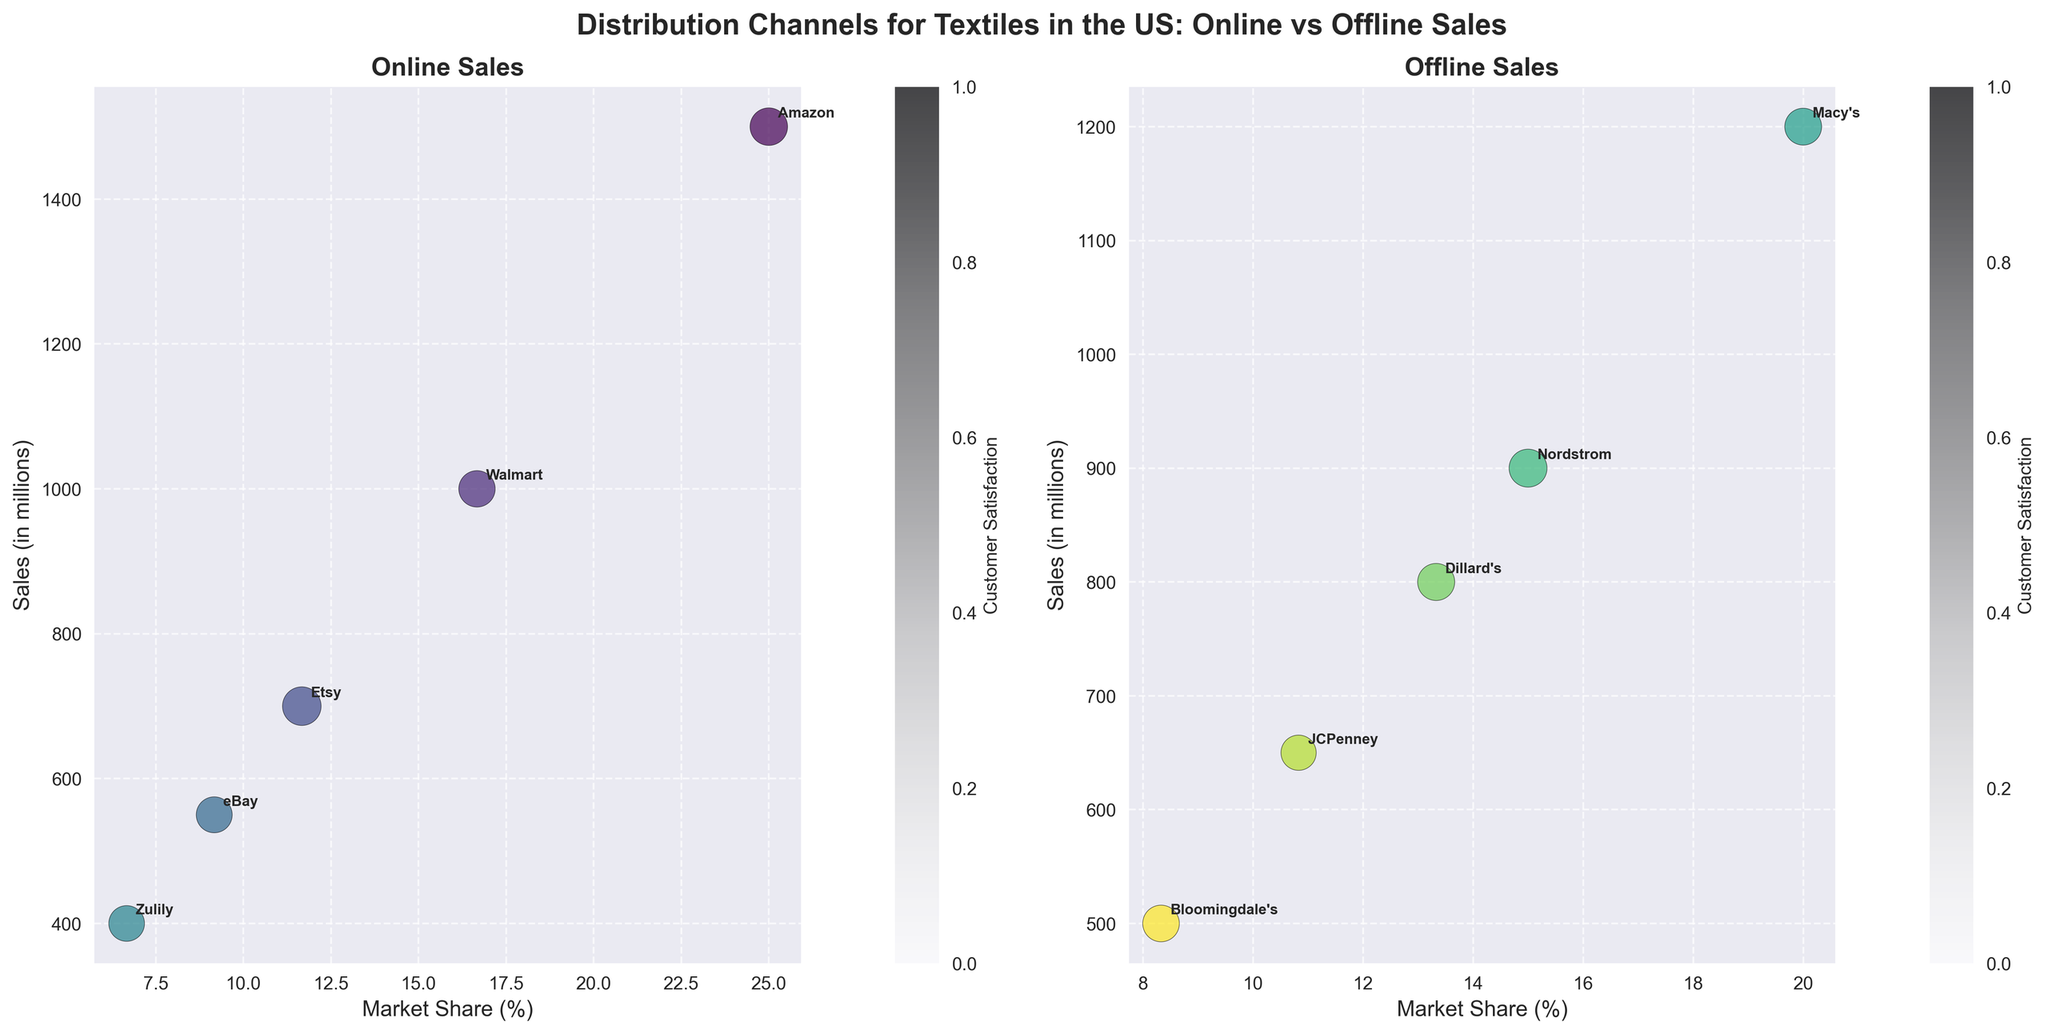What's the title of the subplot? The title is located at the top center of the subplot and summarizes the main idea, which is "Distribution Channels for Textiles in the US: Online vs Offline Sales".
Answer: Distribution Channels for Textiles in the US: Online vs Offline Sales Which company has the highest customer satisfaction in the Online Sales subplot? By examining the bubbles in the Online Sales subplot and checking the customer satisfaction color legend, we can identify that Etsy has the highest customer satisfaction with a value of 90.
Answer: Etsy Which company has the largest market share in the Offline Sales subplot? In the Offline Sales subplot, the company with the largest market share has the furthest right bubble on the x-axis. Macy's bubble is positioned at the highest market share percentage of 20%.
Answer: Macy's What's the approximate size of the bubble for Amazon in the Online Sales subplot? The size of the bubble corresponds to customer satisfaction. The bubble size is proportional, and since Amazon has a customer satisfaction of 85, its bubble size is around 425 (85 * 5).
Answer: 425 Which Online Sales company has lower sales than Dillard's in Offline Sales, but higher customer satisfaction? To find this, we locate Dillard's sales in Offline Sales (800 million) and compare them with Online Sales. Etsy has lower sales (700 million) but a higher customer satisfaction (90).
Answer: Etsy How does the market share of Nordstrom compare to that of Walmart? By comparing the x-axis positions of Nordstrom in the Offline Sales subplot and Walmart in the Online Sales subplot, we see that Nordstrom's market share (15%) is less than Walmart's market share (16.67%).
Answer: Nordstrom has a smaller market share than Walmart What's the average market share of the top three online retailers in terms of sales? The top three online retailers in terms of sales are Amazon (25%), Walmart (16.67%), and Etsy (11.67%). The average is calculated as (25 + 16.67 + 11.67) / 3.
Answer: 17.78% Which subplot has more companies represented, Online or Offline Sales? By counting the number of bubbles in each subplot, we see that the Offline Sales subplot has more companies (5) compared to the Online Sales subplot (5). Both subplots have equal representation.
Answer: Both have equal representation Is the customer satisfaction for Bloomingdale's higher or lower than for eBay? Bloomingdale's (Offline) and eBay (Online) can be compared by checking the color legend. Bloomingdale’s customer satisfaction is 81, while eBay’s is 78. Thus, Bloomingdale's has higher satisfaction.
Answer: Higher Which company in the Offline Sales subplot has the lowest sales, and what is its market share? By looking at the vertical axis and identifying the lowest positioned bubble in the Offline Sales subplot, Bloomingdale's has the lowest sales (500 million) and its market share is 8.33%.
Answer: Bloomingdale's, 8.33% 